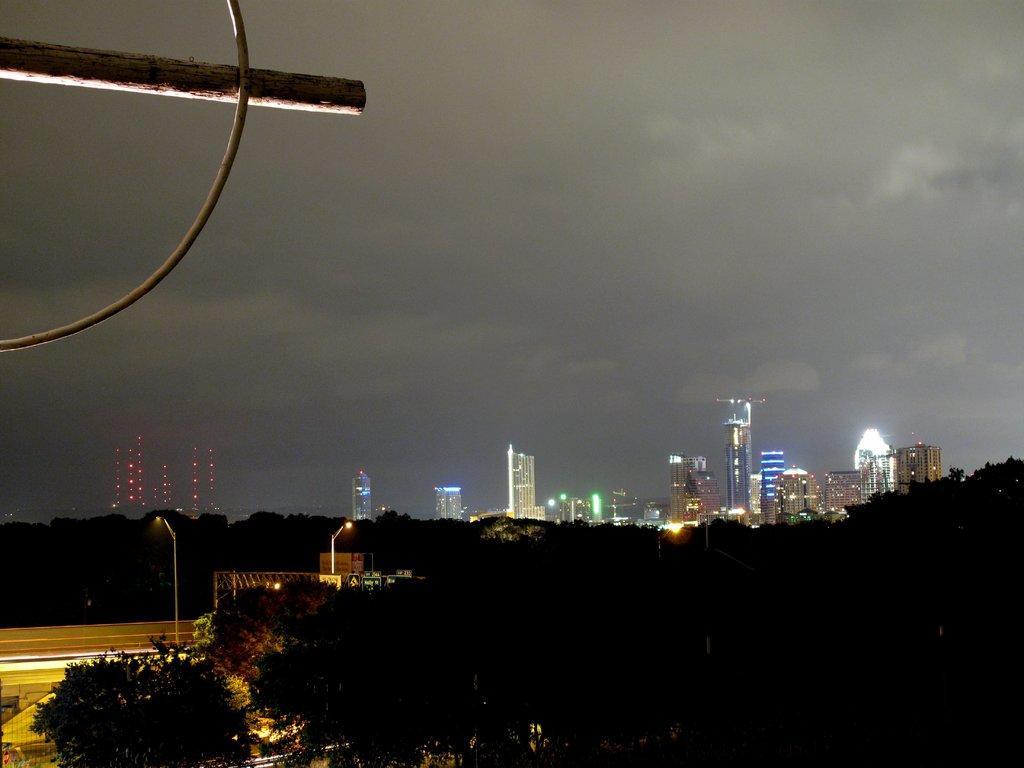Could you give a brief overview of what you see in this image? This picture is clicked outside. In the foreground we can see the trees and we can see the street lights attached to the poles and some other objects. In the background we can see the sky, buildings and lights. In the top left corner we can see some other objects. 